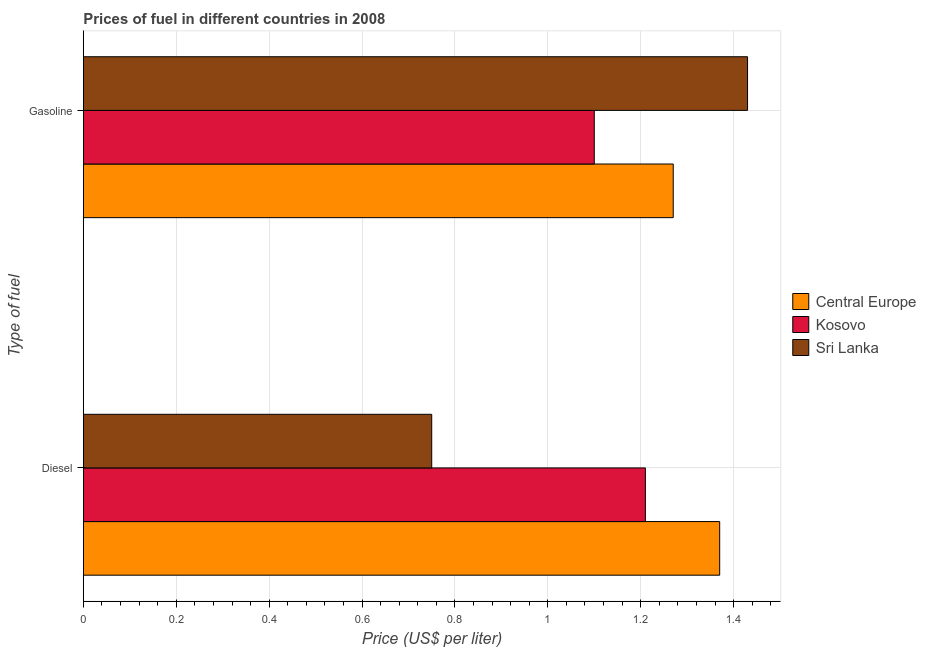How many different coloured bars are there?
Your answer should be compact. 3. Are the number of bars per tick equal to the number of legend labels?
Make the answer very short. Yes. Are the number of bars on each tick of the Y-axis equal?
Give a very brief answer. Yes. How many bars are there on the 1st tick from the top?
Your answer should be compact. 3. How many bars are there on the 1st tick from the bottom?
Ensure brevity in your answer.  3. What is the label of the 2nd group of bars from the top?
Provide a succinct answer. Diesel. Across all countries, what is the maximum gasoline price?
Give a very brief answer. 1.43. In which country was the diesel price maximum?
Keep it short and to the point. Central Europe. In which country was the diesel price minimum?
Give a very brief answer. Sri Lanka. What is the total diesel price in the graph?
Provide a short and direct response. 3.33. What is the difference between the diesel price in Kosovo and that in Sri Lanka?
Make the answer very short. 0.46. What is the difference between the diesel price in Central Europe and the gasoline price in Sri Lanka?
Provide a short and direct response. -0.06. What is the average gasoline price per country?
Offer a very short reply. 1.27. What is the difference between the gasoline price and diesel price in Sri Lanka?
Offer a very short reply. 0.68. In how many countries, is the diesel price greater than 0.04 US$ per litre?
Make the answer very short. 3. What is the ratio of the gasoline price in Kosovo to that in Central Europe?
Provide a short and direct response. 0.87. In how many countries, is the gasoline price greater than the average gasoline price taken over all countries?
Provide a short and direct response. 2. What does the 3rd bar from the top in Diesel represents?
Offer a very short reply. Central Europe. What does the 3rd bar from the bottom in Diesel represents?
Make the answer very short. Sri Lanka. Are the values on the major ticks of X-axis written in scientific E-notation?
Offer a very short reply. No. Does the graph contain any zero values?
Keep it short and to the point. No. How many legend labels are there?
Your response must be concise. 3. What is the title of the graph?
Make the answer very short. Prices of fuel in different countries in 2008. Does "Yemen, Rep." appear as one of the legend labels in the graph?
Offer a terse response. No. What is the label or title of the X-axis?
Ensure brevity in your answer.  Price (US$ per liter). What is the label or title of the Y-axis?
Offer a very short reply. Type of fuel. What is the Price (US$ per liter) of Central Europe in Diesel?
Offer a very short reply. 1.37. What is the Price (US$ per liter) in Kosovo in Diesel?
Offer a terse response. 1.21. What is the Price (US$ per liter) of Sri Lanka in Diesel?
Provide a short and direct response. 0.75. What is the Price (US$ per liter) of Central Europe in Gasoline?
Your answer should be compact. 1.27. What is the Price (US$ per liter) of Kosovo in Gasoline?
Your answer should be compact. 1.1. What is the Price (US$ per liter) in Sri Lanka in Gasoline?
Offer a terse response. 1.43. Across all Type of fuel, what is the maximum Price (US$ per liter) of Central Europe?
Provide a succinct answer. 1.37. Across all Type of fuel, what is the maximum Price (US$ per liter) in Kosovo?
Offer a terse response. 1.21. Across all Type of fuel, what is the maximum Price (US$ per liter) in Sri Lanka?
Your answer should be compact. 1.43. Across all Type of fuel, what is the minimum Price (US$ per liter) of Central Europe?
Offer a very short reply. 1.27. Across all Type of fuel, what is the minimum Price (US$ per liter) of Kosovo?
Provide a succinct answer. 1.1. What is the total Price (US$ per liter) of Central Europe in the graph?
Ensure brevity in your answer.  2.64. What is the total Price (US$ per liter) of Kosovo in the graph?
Your answer should be very brief. 2.31. What is the total Price (US$ per liter) of Sri Lanka in the graph?
Make the answer very short. 2.18. What is the difference between the Price (US$ per liter) of Kosovo in Diesel and that in Gasoline?
Offer a terse response. 0.11. What is the difference between the Price (US$ per liter) of Sri Lanka in Diesel and that in Gasoline?
Make the answer very short. -0.68. What is the difference between the Price (US$ per liter) of Central Europe in Diesel and the Price (US$ per liter) of Kosovo in Gasoline?
Ensure brevity in your answer.  0.27. What is the difference between the Price (US$ per liter) in Central Europe in Diesel and the Price (US$ per liter) in Sri Lanka in Gasoline?
Offer a very short reply. -0.06. What is the difference between the Price (US$ per liter) in Kosovo in Diesel and the Price (US$ per liter) in Sri Lanka in Gasoline?
Offer a very short reply. -0.22. What is the average Price (US$ per liter) in Central Europe per Type of fuel?
Ensure brevity in your answer.  1.32. What is the average Price (US$ per liter) of Kosovo per Type of fuel?
Give a very brief answer. 1.16. What is the average Price (US$ per liter) in Sri Lanka per Type of fuel?
Offer a terse response. 1.09. What is the difference between the Price (US$ per liter) in Central Europe and Price (US$ per liter) in Kosovo in Diesel?
Provide a short and direct response. 0.16. What is the difference between the Price (US$ per liter) in Central Europe and Price (US$ per liter) in Sri Lanka in Diesel?
Keep it short and to the point. 0.62. What is the difference between the Price (US$ per liter) in Kosovo and Price (US$ per liter) in Sri Lanka in Diesel?
Your answer should be very brief. 0.46. What is the difference between the Price (US$ per liter) in Central Europe and Price (US$ per liter) in Kosovo in Gasoline?
Make the answer very short. 0.17. What is the difference between the Price (US$ per liter) of Central Europe and Price (US$ per liter) of Sri Lanka in Gasoline?
Provide a succinct answer. -0.16. What is the difference between the Price (US$ per liter) in Kosovo and Price (US$ per liter) in Sri Lanka in Gasoline?
Your answer should be very brief. -0.33. What is the ratio of the Price (US$ per liter) in Central Europe in Diesel to that in Gasoline?
Provide a succinct answer. 1.08. What is the ratio of the Price (US$ per liter) in Kosovo in Diesel to that in Gasoline?
Ensure brevity in your answer.  1.1. What is the ratio of the Price (US$ per liter) in Sri Lanka in Diesel to that in Gasoline?
Offer a very short reply. 0.52. What is the difference between the highest and the second highest Price (US$ per liter) of Kosovo?
Give a very brief answer. 0.11. What is the difference between the highest and the second highest Price (US$ per liter) in Sri Lanka?
Offer a very short reply. 0.68. What is the difference between the highest and the lowest Price (US$ per liter) in Kosovo?
Keep it short and to the point. 0.11. What is the difference between the highest and the lowest Price (US$ per liter) in Sri Lanka?
Keep it short and to the point. 0.68. 